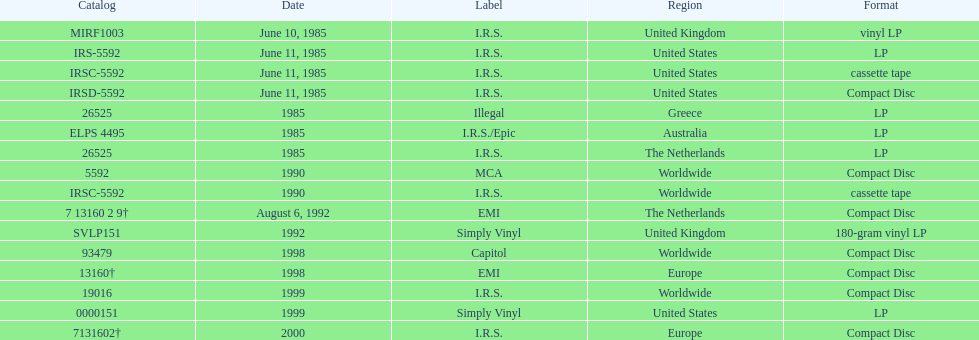Which country or region had the most releases? Worldwide. 